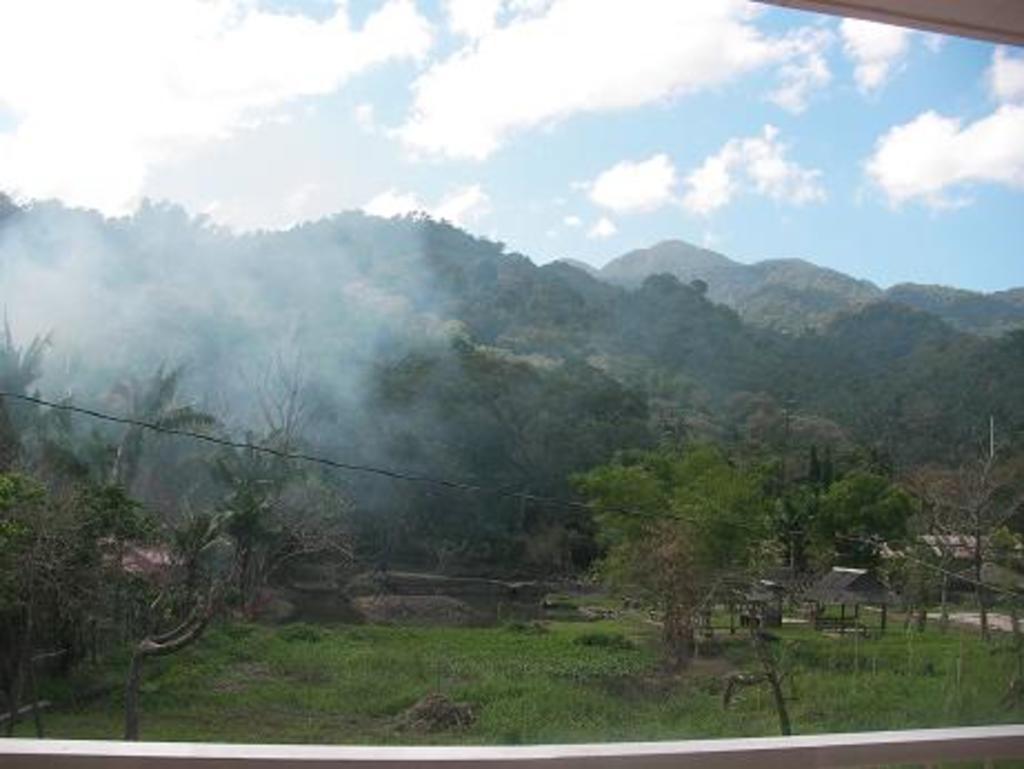Can you describe this image briefly? In the image in the center we can see glass. Through glass,we can see grass,plants,trees,huts,wires etc. In the background we can see sky,clouds,mountain and trees. 